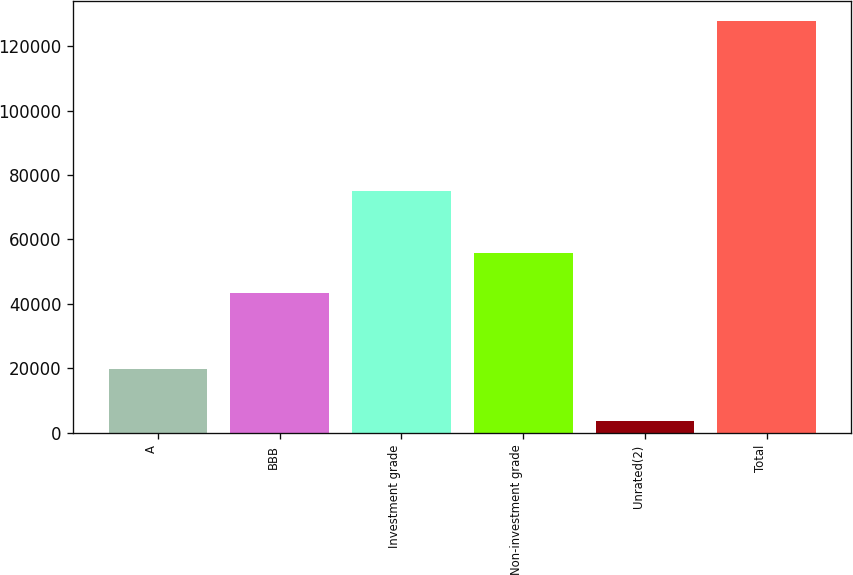<chart> <loc_0><loc_0><loc_500><loc_500><bar_chart><fcel>A<fcel>BBB<fcel>Investment grade<fcel>Non-investment grade<fcel>Unrated(2)<fcel>Total<nl><fcel>19942<fcel>43387<fcel>75080<fcel>55785.8<fcel>3729<fcel>127717<nl></chart> 